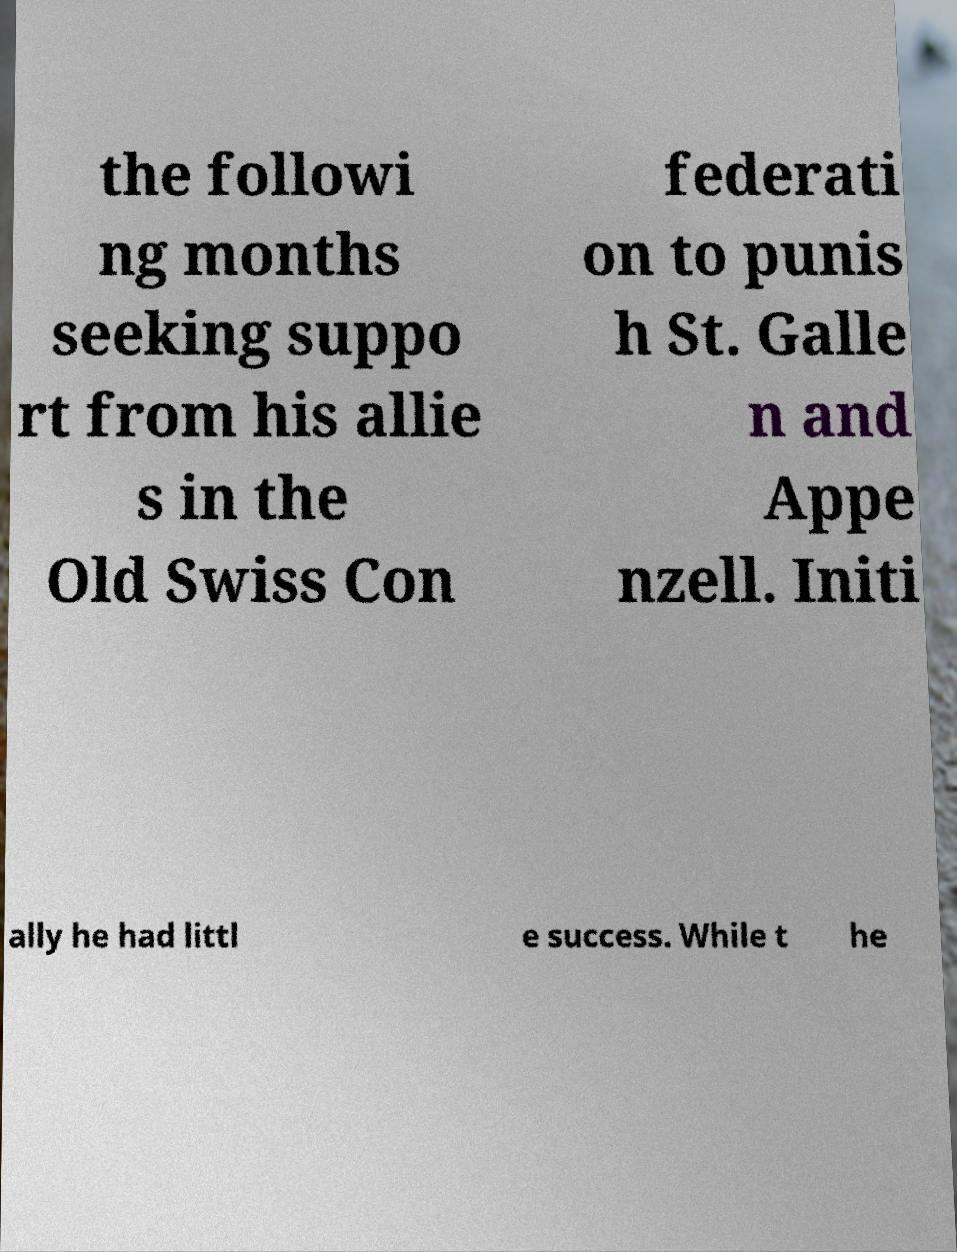Could you assist in decoding the text presented in this image and type it out clearly? the followi ng months seeking suppo rt from his allie s in the Old Swiss Con federati on to punis h St. Galle n and Appe nzell. Initi ally he had littl e success. While t he 